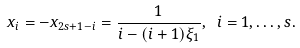<formula> <loc_0><loc_0><loc_500><loc_500>x _ { i } = - x _ { 2 s + 1 - i } = \frac { 1 } { i - ( i + 1 ) \xi _ { 1 } } , \ i = 1 , \dots , s .</formula> 